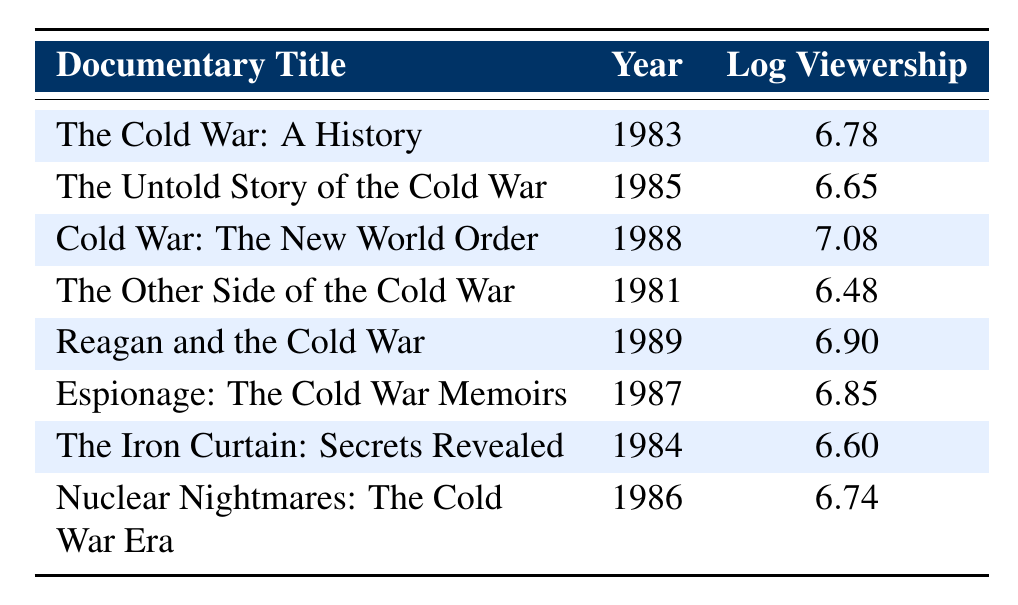What was the viewership rating of "The Cold War: A History"? The table lists "The Cold War: A History" with a viewership rating of 6,000,000.
Answer: 6,000,000 Which documentary released in 1989 had a higher viewership rating, "Reagan and the Cold War" or "Cold War: The New World Order"? "Reagan and the Cold War," with a rating of 8,000,000, is higher than "Cold War: The New World Order," which had a rating of 12,000,000.
Answer: Cold War: The New World Order What is the average viewership rating of the documentaries released between 1981 and 1986? The documentaries are "The Other Side of the Cold War" (3,000,000), "The Iron Curtain: Secrets Revealed" (4,000,000), "Nuclear Nightmares: The Cold War Era" (5,500,000), "The Cold War: A History" (6,000,000), and "The Untold Story of the Cold War" (4,500,000). The total is 23,000,000, and with 5 items, the average is 23,000,000 / 5 = 4,600,000.
Answer: 4,600,000 Did "Espionage: The Cold War Memoirs" have a higher or lower viewership rating than the average viewership rating of all the documentaries? The average viewership rating is calculated as follows: 6,000,000 + 4,500,000 + 12,000,000 + 3,000,000 + 8,000,000 + 7,000,000 + 4,000,000 + 5,500,000 = 50,000,000 divided by 8 equals 6,250,000. Since "Espionage: The Cold War Memoirs" has a rating of 7,000,000, it is higher than the average.
Answer: Higher Which documentary had the lowest viewership rating, and what was that rating? From the table, "The Other Side of the Cold War" has the lowest rating at 3,000,000.
Answer: 3,000,000 